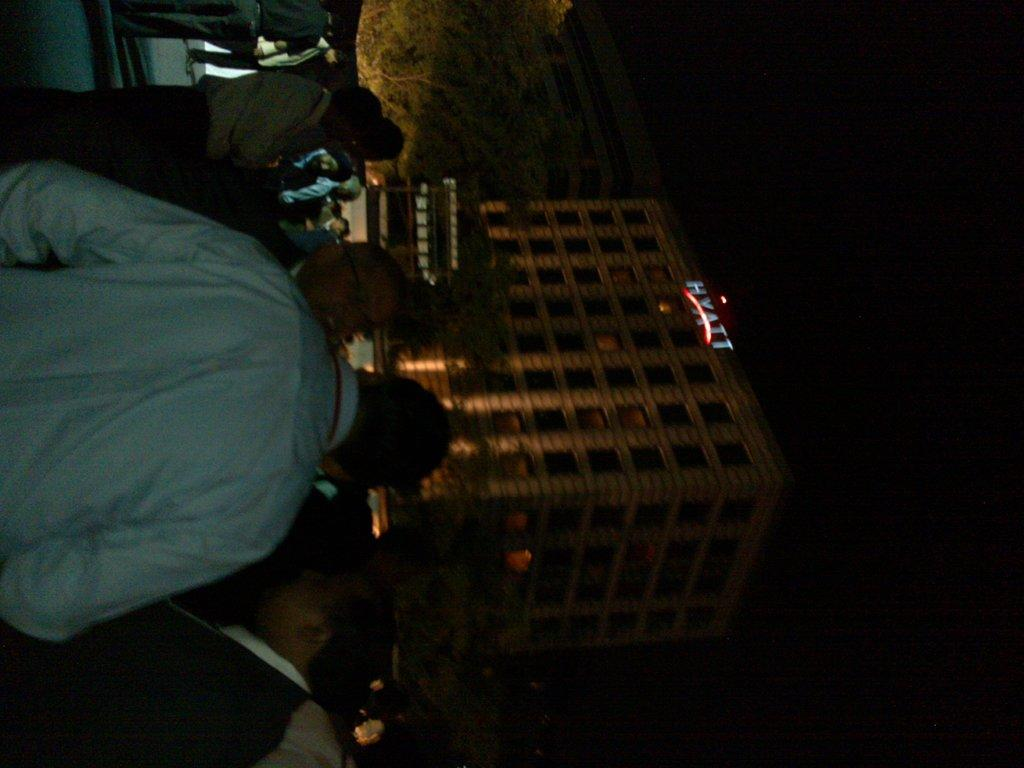What is the main structure in the picture? There is a building in the picture. Are there any people present in the image? Yes, there are people standing in front of the building. What other natural element can be seen in the picture? There is a tree in the picture. What is the reason the mother is standing in the middle of the picture? There is no mother or middle of the picture mentioned in the facts provided. The image only contains a building, people, and a tree. 